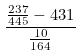<formula> <loc_0><loc_0><loc_500><loc_500>\frac { \frac { 2 3 7 } { 4 4 5 } - 4 3 1 } { \frac { 1 0 } { 1 6 4 } }</formula> 